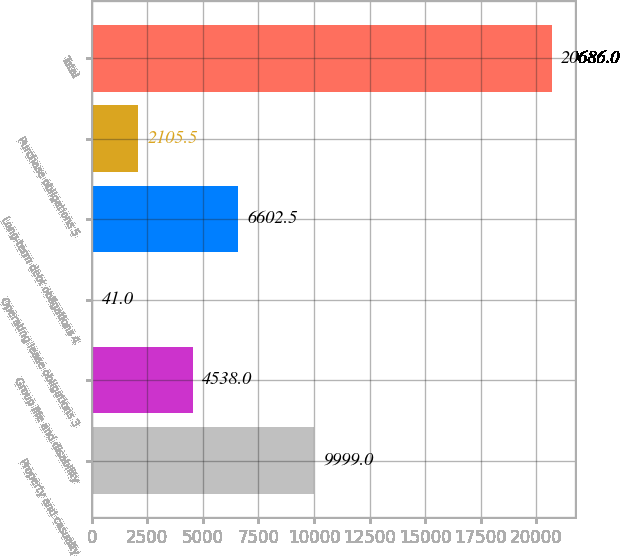<chart> <loc_0><loc_0><loc_500><loc_500><bar_chart><fcel>Property and casualty<fcel>Group life and disability<fcel>Operating lease obligations 3<fcel>Long-term debt obligations 4<fcel>Purchase obligations 5<fcel>Total<nl><fcel>9999<fcel>4538<fcel>41<fcel>6602.5<fcel>2105.5<fcel>20686<nl></chart> 